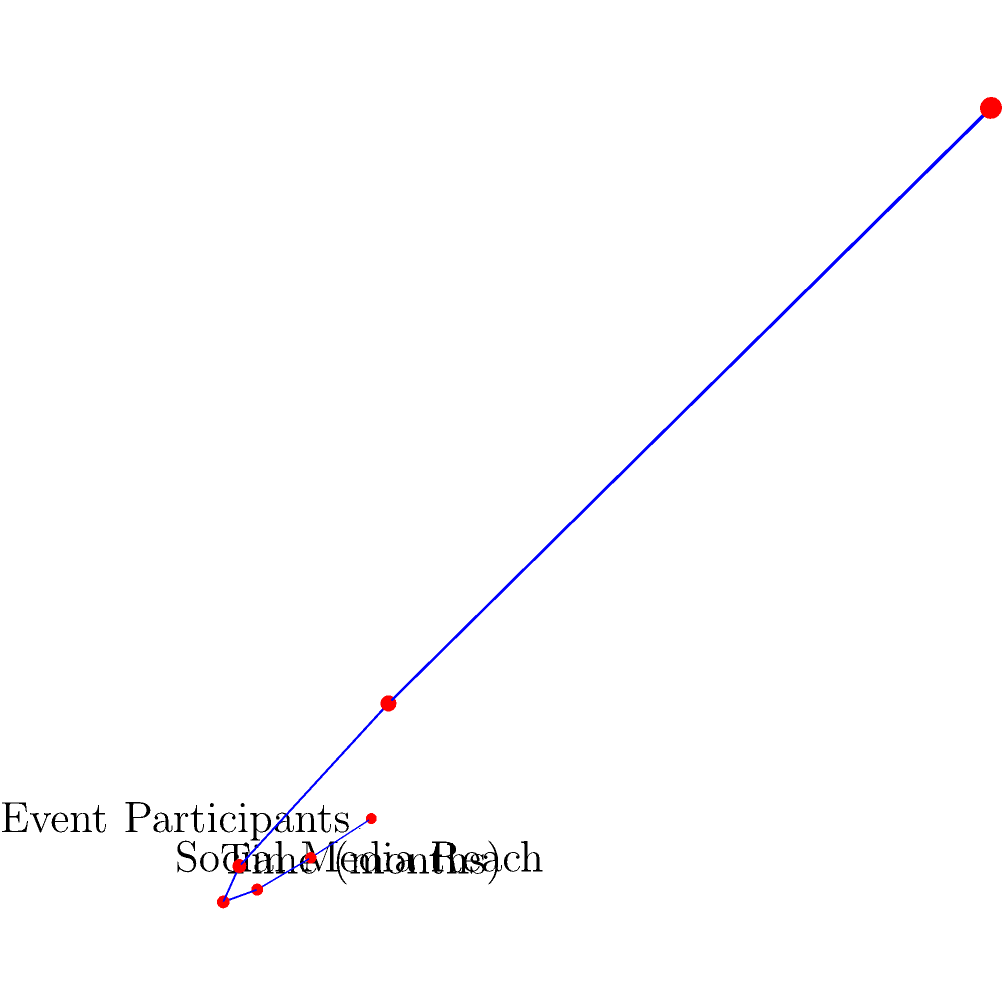A pharmaceutical company is tracking the growth of its awareness campaign over a 6-month period. The 3D coordinate system shows Time (months) on the x-axis, Social Media Reach (in thousands) on the y-axis, and Event Participants (divided by 50 for scale) on the z-axis. Based on the graph, what is the approximate rate of growth for both Social Media Reach and Event Participants each month? To determine the rate of growth for Social Media Reach and Event Participants, we need to analyze the pattern in the data points:

1. Observe the pattern:
   - The curve shows an exponential growth pattern for both metrics.
   - The values appear to double each month.

2. Confirm for Social Media Reach:
   - Month 0: 1,000
   - Month 1: 2,000 (2x)
   - Month 2: 4,000 (2x)
   - Month 3: 8,000 (2x)
   - And so on...

3. Confirm for Event Participants:
   - Month 0: 50
   - Month 1: 100 (2x)
   - Month 2: 200 (2x)
   - Month 3: 400 (2x)
   - And so on...

4. Calculate the growth rate:
   - A doubling each month represents a 100% increase.
   - The growth rate can be expressed as 2x or 100% per month.

Therefore, both Social Media Reach and Event Participants are growing at an approximate rate of 100% or doubling each month.
Answer: 100% per month 